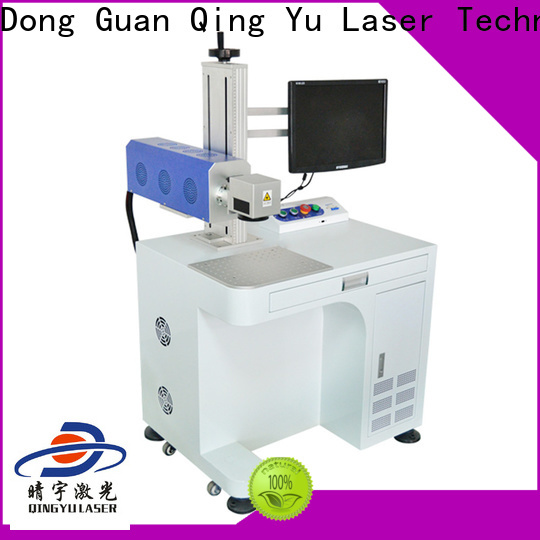Based on the design and features visible in the image, what specific functions or capabilities might this laser engraving machine offer for industrial usage? The laser engraving machine depicted in the image appears to be designed for detailed and precise engraving tasks. It features a guidance system and an extensive control panel, allowing for comprehensive setting adjustments suitable for various materials and tasks. The emergency stop button indicates robust safety measures, critical for industrial settings. The attached monitor likely provides real-time visual feedback, enabling operators to monitor and possibly preview the engraving process, ensuring precision and quality. The grid platform suggests versatility in handling different material sizes and helps manage debris or residue during operations. Additionally, the machine's mobility enables easy relocation within the facility, enhancing its utility for diverse engraving tasks. Therefore, this machine likely excels in offering precision engraving on various materials, enhanced safety features, real-time process monitoring, and operational flexibility within an industrial environment. 